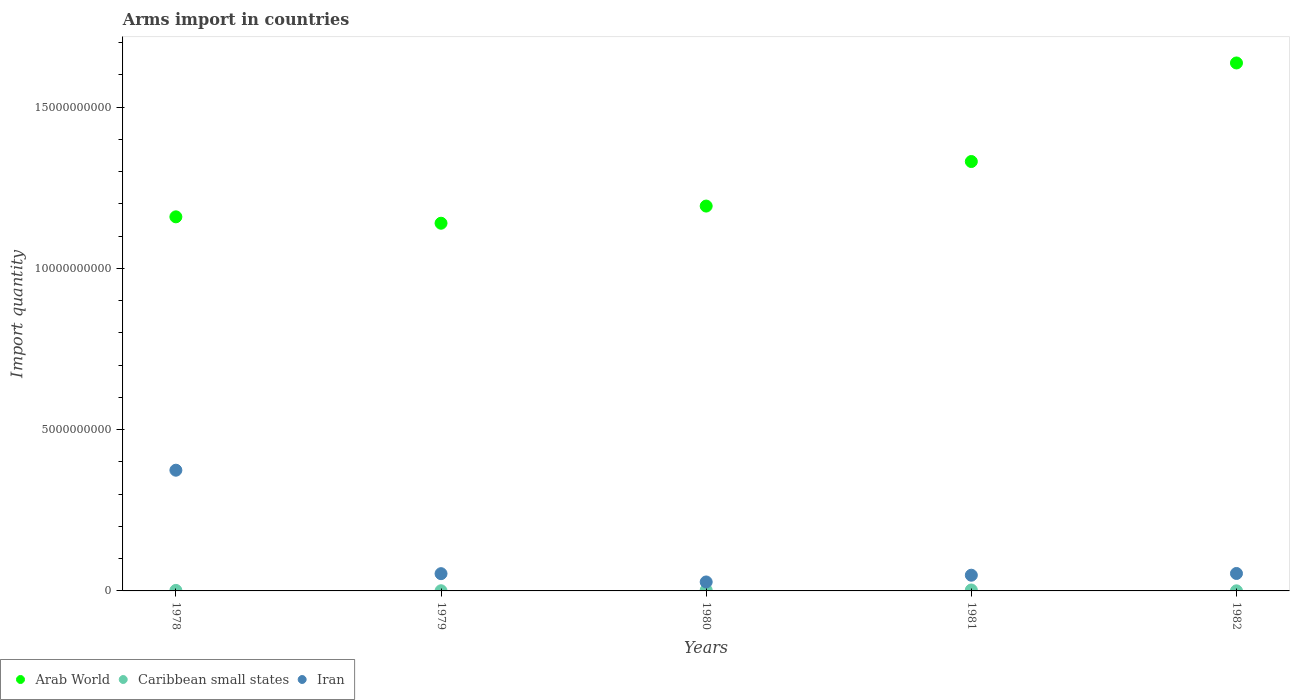How many different coloured dotlines are there?
Give a very brief answer. 3. What is the total arms import in Arab World in 1979?
Your answer should be compact. 1.14e+1. Across all years, what is the maximum total arms import in Iran?
Offer a very short reply. 3.74e+09. Across all years, what is the minimum total arms import in Iran?
Your answer should be very brief. 2.78e+08. In which year was the total arms import in Iran maximum?
Your response must be concise. 1978. In which year was the total arms import in Iran minimum?
Keep it short and to the point. 1980. What is the total total arms import in Caribbean small states in the graph?
Give a very brief answer. 7.90e+07. What is the difference between the total arms import in Arab World in 1979 and that in 1981?
Offer a very short reply. -1.91e+09. What is the difference between the total arms import in Arab World in 1978 and the total arms import in Caribbean small states in 1982?
Provide a short and direct response. 1.16e+1. What is the average total arms import in Caribbean small states per year?
Offer a very short reply. 1.58e+07. In the year 1981, what is the difference between the total arms import in Arab World and total arms import in Caribbean small states?
Your response must be concise. 1.33e+1. In how many years, is the total arms import in Caribbean small states greater than 8000000000?
Your response must be concise. 0. What is the ratio of the total arms import in Iran in 1979 to that in 1980?
Offer a terse response. 1.92. Is the total arms import in Iran in 1978 less than that in 1981?
Your response must be concise. No. Is the difference between the total arms import in Arab World in 1979 and 1982 greater than the difference between the total arms import in Caribbean small states in 1979 and 1982?
Give a very brief answer. No. What is the difference between the highest and the second highest total arms import in Iran?
Your response must be concise. 3.20e+09. What is the difference between the highest and the lowest total arms import in Caribbean small states?
Offer a very short reply. 2.60e+07. In how many years, is the total arms import in Arab World greater than the average total arms import in Arab World taken over all years?
Provide a succinct answer. 2. Is it the case that in every year, the sum of the total arms import in Iran and total arms import in Arab World  is greater than the total arms import in Caribbean small states?
Provide a succinct answer. Yes. Is the total arms import in Iran strictly greater than the total arms import in Arab World over the years?
Ensure brevity in your answer.  No. How many years are there in the graph?
Provide a short and direct response. 5. What is the difference between two consecutive major ticks on the Y-axis?
Offer a very short reply. 5.00e+09. Are the values on the major ticks of Y-axis written in scientific E-notation?
Provide a succinct answer. No. Does the graph contain grids?
Provide a succinct answer. No. Where does the legend appear in the graph?
Provide a succinct answer. Bottom left. How many legend labels are there?
Keep it short and to the point. 3. What is the title of the graph?
Give a very brief answer. Arms import in countries. Does "South Africa" appear as one of the legend labels in the graph?
Your response must be concise. No. What is the label or title of the Y-axis?
Make the answer very short. Import quantity. What is the Import quantity in Arab World in 1978?
Provide a short and direct response. 1.16e+1. What is the Import quantity in Caribbean small states in 1978?
Offer a very short reply. 1.60e+07. What is the Import quantity in Iran in 1978?
Provide a short and direct response. 3.74e+09. What is the Import quantity of Arab World in 1979?
Provide a succinct answer. 1.14e+1. What is the Import quantity in Iran in 1979?
Keep it short and to the point. 5.35e+08. What is the Import quantity in Arab World in 1980?
Ensure brevity in your answer.  1.19e+1. What is the Import quantity in Caribbean small states in 1980?
Give a very brief answer. 2.60e+07. What is the Import quantity of Iran in 1980?
Provide a succinct answer. 2.78e+08. What is the Import quantity of Arab World in 1981?
Provide a succinct answer. 1.33e+1. What is the Import quantity in Caribbean small states in 1981?
Offer a very short reply. 2.90e+07. What is the Import quantity in Iran in 1981?
Your response must be concise. 4.87e+08. What is the Import quantity of Arab World in 1982?
Offer a very short reply. 1.64e+1. What is the Import quantity in Iran in 1982?
Offer a very short reply. 5.41e+08. Across all years, what is the maximum Import quantity of Arab World?
Your response must be concise. 1.64e+1. Across all years, what is the maximum Import quantity of Caribbean small states?
Your answer should be very brief. 2.90e+07. Across all years, what is the maximum Import quantity of Iran?
Your answer should be compact. 3.74e+09. Across all years, what is the minimum Import quantity of Arab World?
Make the answer very short. 1.14e+1. Across all years, what is the minimum Import quantity of Caribbean small states?
Your answer should be compact. 3.00e+06. Across all years, what is the minimum Import quantity of Iran?
Offer a very short reply. 2.78e+08. What is the total Import quantity in Arab World in the graph?
Your response must be concise. 6.46e+1. What is the total Import quantity in Caribbean small states in the graph?
Keep it short and to the point. 7.90e+07. What is the total Import quantity in Iran in the graph?
Your response must be concise. 5.58e+09. What is the difference between the Import quantity of Arab World in 1978 and that in 1979?
Your answer should be very brief. 1.98e+08. What is the difference between the Import quantity of Caribbean small states in 1978 and that in 1979?
Your answer should be compact. 1.10e+07. What is the difference between the Import quantity of Iran in 1978 and that in 1979?
Ensure brevity in your answer.  3.21e+09. What is the difference between the Import quantity in Arab World in 1978 and that in 1980?
Ensure brevity in your answer.  -3.34e+08. What is the difference between the Import quantity in Caribbean small states in 1978 and that in 1980?
Your response must be concise. -1.00e+07. What is the difference between the Import quantity of Iran in 1978 and that in 1980?
Give a very brief answer. 3.46e+09. What is the difference between the Import quantity in Arab World in 1978 and that in 1981?
Ensure brevity in your answer.  -1.72e+09. What is the difference between the Import quantity of Caribbean small states in 1978 and that in 1981?
Keep it short and to the point. -1.30e+07. What is the difference between the Import quantity of Iran in 1978 and that in 1981?
Ensure brevity in your answer.  3.26e+09. What is the difference between the Import quantity in Arab World in 1978 and that in 1982?
Give a very brief answer. -4.77e+09. What is the difference between the Import quantity of Caribbean small states in 1978 and that in 1982?
Provide a succinct answer. 1.30e+07. What is the difference between the Import quantity of Iran in 1978 and that in 1982?
Provide a short and direct response. 3.20e+09. What is the difference between the Import quantity of Arab World in 1979 and that in 1980?
Ensure brevity in your answer.  -5.32e+08. What is the difference between the Import quantity of Caribbean small states in 1979 and that in 1980?
Provide a short and direct response. -2.10e+07. What is the difference between the Import quantity of Iran in 1979 and that in 1980?
Your response must be concise. 2.57e+08. What is the difference between the Import quantity in Arab World in 1979 and that in 1981?
Give a very brief answer. -1.91e+09. What is the difference between the Import quantity of Caribbean small states in 1979 and that in 1981?
Ensure brevity in your answer.  -2.40e+07. What is the difference between the Import quantity in Iran in 1979 and that in 1981?
Provide a short and direct response. 4.80e+07. What is the difference between the Import quantity in Arab World in 1979 and that in 1982?
Your answer should be compact. -4.97e+09. What is the difference between the Import quantity in Caribbean small states in 1979 and that in 1982?
Your answer should be compact. 2.00e+06. What is the difference between the Import quantity of Iran in 1979 and that in 1982?
Keep it short and to the point. -6.00e+06. What is the difference between the Import quantity of Arab World in 1980 and that in 1981?
Give a very brief answer. -1.38e+09. What is the difference between the Import quantity of Caribbean small states in 1980 and that in 1981?
Offer a terse response. -3.00e+06. What is the difference between the Import quantity in Iran in 1980 and that in 1981?
Offer a terse response. -2.09e+08. What is the difference between the Import quantity in Arab World in 1980 and that in 1982?
Make the answer very short. -4.44e+09. What is the difference between the Import quantity of Caribbean small states in 1980 and that in 1982?
Keep it short and to the point. 2.30e+07. What is the difference between the Import quantity in Iran in 1980 and that in 1982?
Your answer should be compact. -2.63e+08. What is the difference between the Import quantity of Arab World in 1981 and that in 1982?
Your answer should be compact. -3.06e+09. What is the difference between the Import quantity of Caribbean small states in 1981 and that in 1982?
Provide a short and direct response. 2.60e+07. What is the difference between the Import quantity of Iran in 1981 and that in 1982?
Offer a very short reply. -5.40e+07. What is the difference between the Import quantity of Arab World in 1978 and the Import quantity of Caribbean small states in 1979?
Your answer should be very brief. 1.16e+1. What is the difference between the Import quantity in Arab World in 1978 and the Import quantity in Iran in 1979?
Make the answer very short. 1.11e+1. What is the difference between the Import quantity of Caribbean small states in 1978 and the Import quantity of Iran in 1979?
Keep it short and to the point. -5.19e+08. What is the difference between the Import quantity of Arab World in 1978 and the Import quantity of Caribbean small states in 1980?
Give a very brief answer. 1.16e+1. What is the difference between the Import quantity of Arab World in 1978 and the Import quantity of Iran in 1980?
Offer a terse response. 1.13e+1. What is the difference between the Import quantity of Caribbean small states in 1978 and the Import quantity of Iran in 1980?
Your answer should be compact. -2.62e+08. What is the difference between the Import quantity of Arab World in 1978 and the Import quantity of Caribbean small states in 1981?
Provide a short and direct response. 1.16e+1. What is the difference between the Import quantity of Arab World in 1978 and the Import quantity of Iran in 1981?
Offer a very short reply. 1.11e+1. What is the difference between the Import quantity of Caribbean small states in 1978 and the Import quantity of Iran in 1981?
Give a very brief answer. -4.71e+08. What is the difference between the Import quantity of Arab World in 1978 and the Import quantity of Caribbean small states in 1982?
Your response must be concise. 1.16e+1. What is the difference between the Import quantity in Arab World in 1978 and the Import quantity in Iran in 1982?
Provide a succinct answer. 1.11e+1. What is the difference between the Import quantity of Caribbean small states in 1978 and the Import quantity of Iran in 1982?
Offer a very short reply. -5.25e+08. What is the difference between the Import quantity in Arab World in 1979 and the Import quantity in Caribbean small states in 1980?
Provide a short and direct response. 1.14e+1. What is the difference between the Import quantity of Arab World in 1979 and the Import quantity of Iran in 1980?
Your answer should be very brief. 1.11e+1. What is the difference between the Import quantity of Caribbean small states in 1979 and the Import quantity of Iran in 1980?
Make the answer very short. -2.73e+08. What is the difference between the Import quantity of Arab World in 1979 and the Import quantity of Caribbean small states in 1981?
Provide a succinct answer. 1.14e+1. What is the difference between the Import quantity of Arab World in 1979 and the Import quantity of Iran in 1981?
Offer a terse response. 1.09e+1. What is the difference between the Import quantity of Caribbean small states in 1979 and the Import quantity of Iran in 1981?
Ensure brevity in your answer.  -4.82e+08. What is the difference between the Import quantity of Arab World in 1979 and the Import quantity of Caribbean small states in 1982?
Give a very brief answer. 1.14e+1. What is the difference between the Import quantity of Arab World in 1979 and the Import quantity of Iran in 1982?
Ensure brevity in your answer.  1.09e+1. What is the difference between the Import quantity in Caribbean small states in 1979 and the Import quantity in Iran in 1982?
Your answer should be compact. -5.36e+08. What is the difference between the Import quantity of Arab World in 1980 and the Import quantity of Caribbean small states in 1981?
Keep it short and to the point. 1.19e+1. What is the difference between the Import quantity of Arab World in 1980 and the Import quantity of Iran in 1981?
Provide a short and direct response. 1.14e+1. What is the difference between the Import quantity of Caribbean small states in 1980 and the Import quantity of Iran in 1981?
Offer a very short reply. -4.61e+08. What is the difference between the Import quantity in Arab World in 1980 and the Import quantity in Caribbean small states in 1982?
Offer a very short reply. 1.19e+1. What is the difference between the Import quantity in Arab World in 1980 and the Import quantity in Iran in 1982?
Your response must be concise. 1.14e+1. What is the difference between the Import quantity in Caribbean small states in 1980 and the Import quantity in Iran in 1982?
Make the answer very short. -5.15e+08. What is the difference between the Import quantity of Arab World in 1981 and the Import quantity of Caribbean small states in 1982?
Offer a very short reply. 1.33e+1. What is the difference between the Import quantity of Arab World in 1981 and the Import quantity of Iran in 1982?
Give a very brief answer. 1.28e+1. What is the difference between the Import quantity in Caribbean small states in 1981 and the Import quantity in Iran in 1982?
Your answer should be compact. -5.12e+08. What is the average Import quantity in Arab World per year?
Your answer should be very brief. 1.29e+1. What is the average Import quantity in Caribbean small states per year?
Give a very brief answer. 1.58e+07. What is the average Import quantity of Iran per year?
Provide a short and direct response. 1.12e+09. In the year 1978, what is the difference between the Import quantity of Arab World and Import quantity of Caribbean small states?
Your response must be concise. 1.16e+1. In the year 1978, what is the difference between the Import quantity in Arab World and Import quantity in Iran?
Your response must be concise. 7.86e+09. In the year 1978, what is the difference between the Import quantity in Caribbean small states and Import quantity in Iran?
Offer a terse response. -3.73e+09. In the year 1979, what is the difference between the Import quantity in Arab World and Import quantity in Caribbean small states?
Give a very brief answer. 1.14e+1. In the year 1979, what is the difference between the Import quantity of Arab World and Import quantity of Iran?
Make the answer very short. 1.09e+1. In the year 1979, what is the difference between the Import quantity of Caribbean small states and Import quantity of Iran?
Offer a very short reply. -5.30e+08. In the year 1980, what is the difference between the Import quantity in Arab World and Import quantity in Caribbean small states?
Offer a very short reply. 1.19e+1. In the year 1980, what is the difference between the Import quantity in Arab World and Import quantity in Iran?
Your answer should be compact. 1.17e+1. In the year 1980, what is the difference between the Import quantity in Caribbean small states and Import quantity in Iran?
Your response must be concise. -2.52e+08. In the year 1981, what is the difference between the Import quantity of Arab World and Import quantity of Caribbean small states?
Give a very brief answer. 1.33e+1. In the year 1981, what is the difference between the Import quantity in Arab World and Import quantity in Iran?
Your answer should be very brief. 1.28e+1. In the year 1981, what is the difference between the Import quantity of Caribbean small states and Import quantity of Iran?
Your answer should be very brief. -4.58e+08. In the year 1982, what is the difference between the Import quantity of Arab World and Import quantity of Caribbean small states?
Keep it short and to the point. 1.64e+1. In the year 1982, what is the difference between the Import quantity in Arab World and Import quantity in Iran?
Offer a very short reply. 1.58e+1. In the year 1982, what is the difference between the Import quantity of Caribbean small states and Import quantity of Iran?
Offer a very short reply. -5.38e+08. What is the ratio of the Import quantity in Arab World in 1978 to that in 1979?
Your response must be concise. 1.02. What is the ratio of the Import quantity in Caribbean small states in 1978 to that in 1979?
Give a very brief answer. 3.2. What is the ratio of the Import quantity in Iran in 1978 to that in 1979?
Provide a short and direct response. 7. What is the ratio of the Import quantity of Caribbean small states in 1978 to that in 1980?
Ensure brevity in your answer.  0.62. What is the ratio of the Import quantity in Iran in 1978 to that in 1980?
Your answer should be compact. 13.46. What is the ratio of the Import quantity of Arab World in 1978 to that in 1981?
Offer a terse response. 0.87. What is the ratio of the Import quantity in Caribbean small states in 1978 to that in 1981?
Give a very brief answer. 0.55. What is the ratio of the Import quantity in Iran in 1978 to that in 1981?
Keep it short and to the point. 7.69. What is the ratio of the Import quantity of Arab World in 1978 to that in 1982?
Your answer should be very brief. 0.71. What is the ratio of the Import quantity of Caribbean small states in 1978 to that in 1982?
Provide a succinct answer. 5.33. What is the ratio of the Import quantity of Iran in 1978 to that in 1982?
Offer a terse response. 6.92. What is the ratio of the Import quantity in Arab World in 1979 to that in 1980?
Give a very brief answer. 0.96. What is the ratio of the Import quantity of Caribbean small states in 1979 to that in 1980?
Your answer should be compact. 0.19. What is the ratio of the Import quantity of Iran in 1979 to that in 1980?
Make the answer very short. 1.92. What is the ratio of the Import quantity in Arab World in 1979 to that in 1981?
Provide a short and direct response. 0.86. What is the ratio of the Import quantity in Caribbean small states in 1979 to that in 1981?
Your response must be concise. 0.17. What is the ratio of the Import quantity of Iran in 1979 to that in 1981?
Provide a short and direct response. 1.1. What is the ratio of the Import quantity in Arab World in 1979 to that in 1982?
Your answer should be compact. 0.7. What is the ratio of the Import quantity of Iran in 1979 to that in 1982?
Your answer should be compact. 0.99. What is the ratio of the Import quantity of Arab World in 1980 to that in 1981?
Your response must be concise. 0.9. What is the ratio of the Import quantity of Caribbean small states in 1980 to that in 1981?
Offer a terse response. 0.9. What is the ratio of the Import quantity in Iran in 1980 to that in 1981?
Your response must be concise. 0.57. What is the ratio of the Import quantity of Arab World in 1980 to that in 1982?
Ensure brevity in your answer.  0.73. What is the ratio of the Import quantity in Caribbean small states in 1980 to that in 1982?
Keep it short and to the point. 8.67. What is the ratio of the Import quantity in Iran in 1980 to that in 1982?
Make the answer very short. 0.51. What is the ratio of the Import quantity in Arab World in 1981 to that in 1982?
Offer a terse response. 0.81. What is the ratio of the Import quantity of Caribbean small states in 1981 to that in 1982?
Provide a short and direct response. 9.67. What is the ratio of the Import quantity of Iran in 1981 to that in 1982?
Your answer should be compact. 0.9. What is the difference between the highest and the second highest Import quantity of Arab World?
Provide a short and direct response. 3.06e+09. What is the difference between the highest and the second highest Import quantity in Iran?
Your answer should be very brief. 3.20e+09. What is the difference between the highest and the lowest Import quantity in Arab World?
Your response must be concise. 4.97e+09. What is the difference between the highest and the lowest Import quantity of Caribbean small states?
Ensure brevity in your answer.  2.60e+07. What is the difference between the highest and the lowest Import quantity of Iran?
Give a very brief answer. 3.46e+09. 